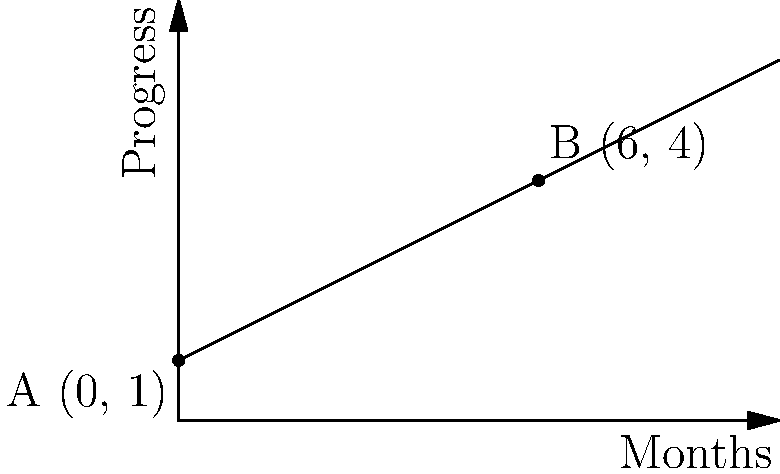A client sets a personal goal and tracks their progress over time. The graph shows their progress, where the x-axis represents months and the y-axis represents a measure of progress. Point A (0, 1) marks the start, and point B (6, 4) represents their progress after 6 months. What does the slope of this line represent in terms of the client's goal achievement, and what is its value? To understand and calculate the slope of the line:

1) The slope represents the rate of progress per month towards the client's goal.

2) We can calculate the slope using the formula:
   $$ \text{slope} = \frac{\text{change in y}}{\text{change in x}} = \frac{y_2 - y_1}{x_2 - x_1} $$

3) Using points A (0, 1) and B (6, 4):
   $$ \text{slope} = \frac{4 - 1}{6 - 0} = \frac{3}{6} = 0.5 $$

4) This means the client's progress increases by 0.5 units per month.

5) In the context of goal achievement, this represents steady, consistent progress over time.

6) The positive slope indicates the client is moving towards their goal, rather than away from it or stagnating.
Answer: The slope is 0.5, representing a progress rate of 0.5 units per month towards the client's goal. 